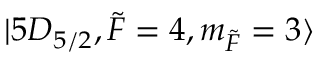Convert formula to latex. <formula><loc_0><loc_0><loc_500><loc_500>| 5 D _ { 5 / 2 } , \tilde { F } = 4 , m _ { \tilde { F } } = 3 \rangle</formula> 